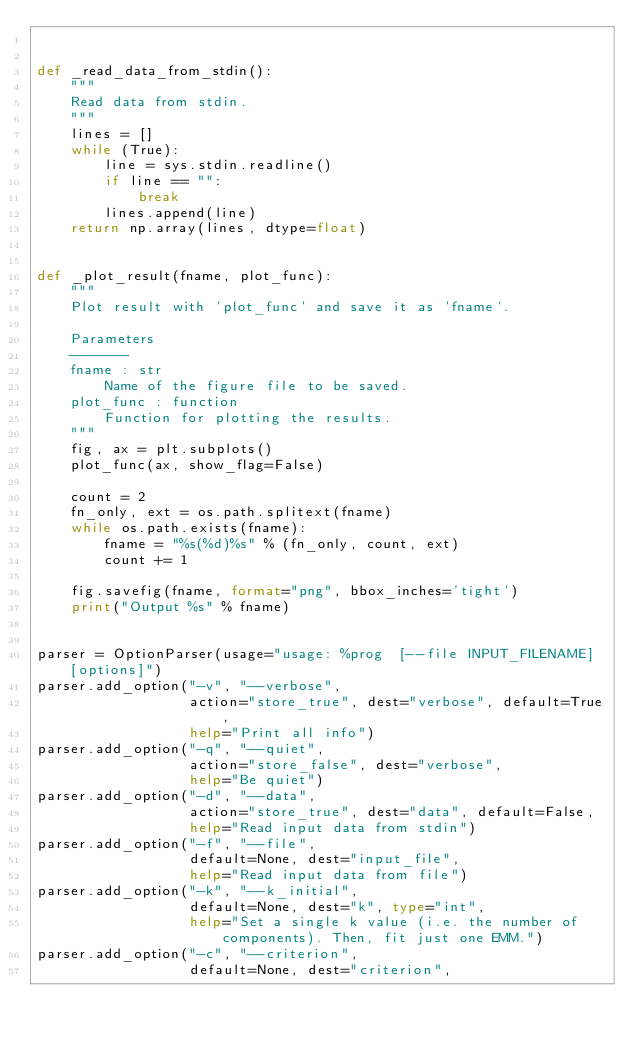Convert code to text. <code><loc_0><loc_0><loc_500><loc_500><_Python_>

def _read_data_from_stdin():
    """
    Read data from stdin.
    """
    lines = []
    while (True):
        line = sys.stdin.readline()
        if line == "":
            break
        lines.append(line)
    return np.array(lines, dtype=float)


def _plot_result(fname, plot_func):
    """
    Plot result with 'plot_func' and save it as 'fname'.

    Parameters
    -------
    fname : str
        Name of the figure file to be saved.
    plot_func : function
        Function for plotting the results.
    """
    fig, ax = plt.subplots()
    plot_func(ax, show_flag=False)

    count = 2
    fn_only, ext = os.path.splitext(fname)
    while os.path.exists(fname):
        fname = "%s(%d)%s" % (fn_only, count, ext)
        count += 1

    fig.savefig(fname, format="png", bbox_inches='tight')
    print("Output %s" % fname)


parser = OptionParser(usage="usage: %prog  [--file INPUT_FILENAME] [options]")
parser.add_option("-v", "--verbose",
                  action="store_true", dest="verbose", default=True,
                  help="Print all info")
parser.add_option("-q", "--quiet",
                  action="store_false", dest="verbose",
                  help="Be quiet")
parser.add_option("-d", "--data",
                  action="store_true", dest="data", default=False,
                  help="Read input data from stdin")
parser.add_option("-f", "--file",
                  default=None, dest="input_file",
                  help="Read input data from file")
parser.add_option("-k", "--k_initial",
                  default=None, dest="k", type="int",
                  help="Set a single k value (i.e. the number of components). Then, fit just one EMM.")
parser.add_option("-c", "--criterion",
                  default=None, dest="criterion",</code> 